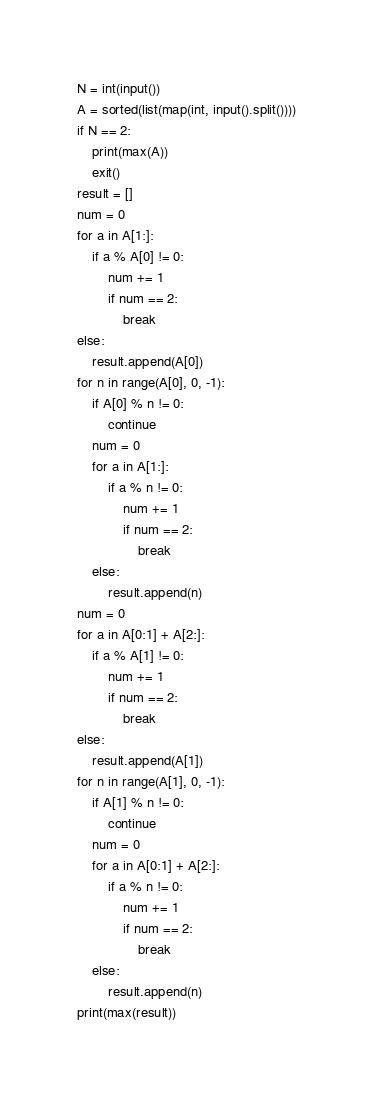<code> <loc_0><loc_0><loc_500><loc_500><_Python_>N = int(input())
A = sorted(list(map(int, input().split())))
if N == 2:
    print(max(A))
    exit()
result = []
num = 0
for a in A[1:]:
    if a % A[0] != 0:
        num += 1
        if num == 2:
            break
else:
    result.append(A[0])
for n in range(A[0], 0, -1):
    if A[0] % n != 0:
        continue
    num = 0
    for a in A[1:]:
        if a % n != 0:
            num += 1
            if num == 2:
                break
    else:
        result.append(n)
num = 0
for a in A[0:1] + A[2:]:
    if a % A[1] != 0:
        num += 1
        if num == 2:
            break
else:
    result.append(A[1])
for n in range(A[1], 0, -1):
    if A[1] % n != 0:
        continue
    num = 0
    for a in A[0:1] + A[2:]:
        if a % n != 0:
            num += 1
            if num == 2:
                break
    else:
        result.append(n)
print(max(result))
</code> 